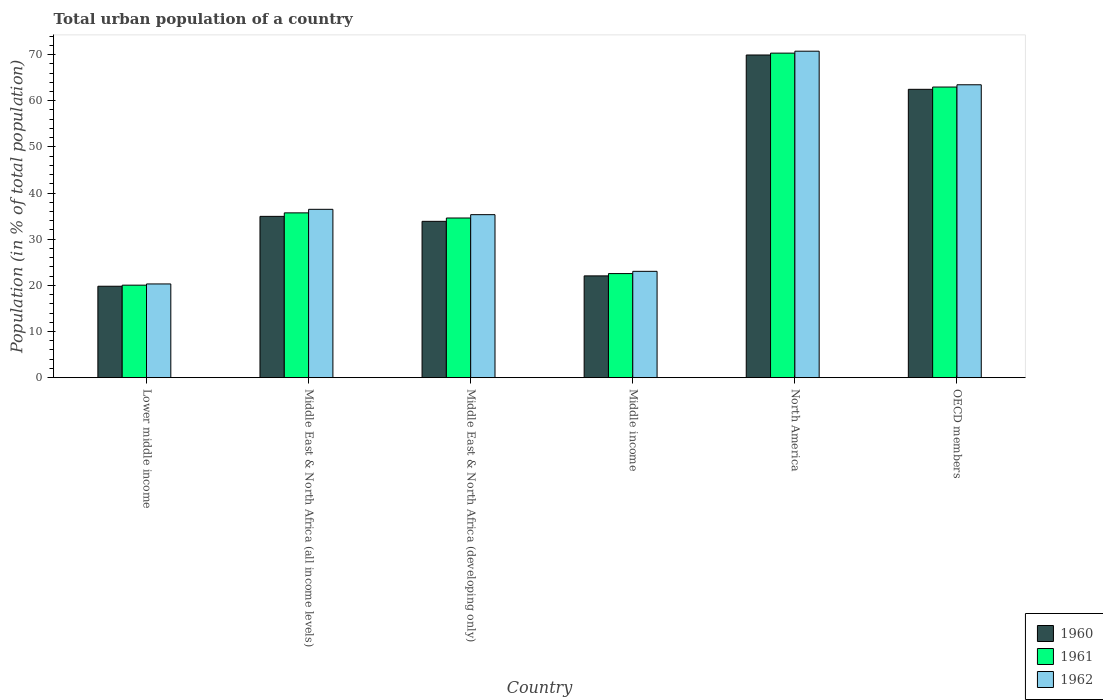How many different coloured bars are there?
Ensure brevity in your answer.  3. How many groups of bars are there?
Your response must be concise. 6. How many bars are there on the 3rd tick from the right?
Make the answer very short. 3. What is the label of the 2nd group of bars from the left?
Give a very brief answer. Middle East & North Africa (all income levels). In how many cases, is the number of bars for a given country not equal to the number of legend labels?
Your response must be concise. 0. What is the urban population in 1962 in North America?
Offer a very short reply. 70.74. Across all countries, what is the maximum urban population in 1960?
Your answer should be compact. 69.92. Across all countries, what is the minimum urban population in 1960?
Offer a very short reply. 19.81. In which country was the urban population in 1960 maximum?
Ensure brevity in your answer.  North America. In which country was the urban population in 1961 minimum?
Keep it short and to the point. Lower middle income. What is the total urban population in 1960 in the graph?
Provide a succinct answer. 243.09. What is the difference between the urban population in 1960 in Lower middle income and that in Middle East & North Africa (developing only)?
Your response must be concise. -14.06. What is the difference between the urban population in 1961 in Middle income and the urban population in 1962 in OECD members?
Provide a succinct answer. -40.91. What is the average urban population in 1962 per country?
Give a very brief answer. 41.56. What is the difference between the urban population of/in 1960 and urban population of/in 1961 in Middle East & North Africa (developing only)?
Your response must be concise. -0.72. In how many countries, is the urban population in 1960 greater than 34 %?
Your answer should be very brief. 3. What is the ratio of the urban population in 1962 in Middle East & North Africa (all income levels) to that in Middle East & North Africa (developing only)?
Make the answer very short. 1.03. Is the urban population in 1961 in Lower middle income less than that in Middle East & North Africa (all income levels)?
Your response must be concise. Yes. Is the difference between the urban population in 1960 in Middle income and North America greater than the difference between the urban population in 1961 in Middle income and North America?
Your answer should be compact. No. What is the difference between the highest and the second highest urban population in 1961?
Provide a succinct answer. 27.26. What is the difference between the highest and the lowest urban population in 1961?
Give a very brief answer. 50.28. Is the sum of the urban population in 1962 in Middle income and OECD members greater than the maximum urban population in 1960 across all countries?
Provide a short and direct response. Yes. What does the 1st bar from the right in Lower middle income represents?
Make the answer very short. 1962. Is it the case that in every country, the sum of the urban population in 1961 and urban population in 1962 is greater than the urban population in 1960?
Give a very brief answer. Yes. Are all the bars in the graph horizontal?
Make the answer very short. No. Are the values on the major ticks of Y-axis written in scientific E-notation?
Your response must be concise. No. Does the graph contain any zero values?
Make the answer very short. No. Does the graph contain grids?
Provide a short and direct response. No. Where does the legend appear in the graph?
Provide a short and direct response. Bottom right. How are the legend labels stacked?
Keep it short and to the point. Vertical. What is the title of the graph?
Ensure brevity in your answer.  Total urban population of a country. Does "2003" appear as one of the legend labels in the graph?
Provide a short and direct response. No. What is the label or title of the X-axis?
Provide a short and direct response. Country. What is the label or title of the Y-axis?
Make the answer very short. Population (in % of total population). What is the Population (in % of total population) in 1960 in Lower middle income?
Provide a succinct answer. 19.81. What is the Population (in % of total population) in 1961 in Lower middle income?
Provide a short and direct response. 20.04. What is the Population (in % of total population) in 1962 in Lower middle income?
Provide a succinct answer. 20.31. What is the Population (in % of total population) of 1960 in Middle East & North Africa (all income levels)?
Keep it short and to the point. 34.95. What is the Population (in % of total population) in 1961 in Middle East & North Africa (all income levels)?
Your answer should be compact. 35.71. What is the Population (in % of total population) of 1962 in Middle East & North Africa (all income levels)?
Your response must be concise. 36.48. What is the Population (in % of total population) in 1960 in Middle East & North Africa (developing only)?
Provide a short and direct response. 33.88. What is the Population (in % of total population) in 1961 in Middle East & North Africa (developing only)?
Provide a succinct answer. 34.6. What is the Population (in % of total population) in 1962 in Middle East & North Africa (developing only)?
Your answer should be very brief. 35.32. What is the Population (in % of total population) of 1960 in Middle income?
Give a very brief answer. 22.05. What is the Population (in % of total population) in 1961 in Middle income?
Make the answer very short. 22.55. What is the Population (in % of total population) in 1962 in Middle income?
Your answer should be very brief. 23.04. What is the Population (in % of total population) of 1960 in North America?
Provide a succinct answer. 69.92. What is the Population (in % of total population) of 1961 in North America?
Provide a succinct answer. 70.32. What is the Population (in % of total population) of 1962 in North America?
Provide a succinct answer. 70.74. What is the Population (in % of total population) in 1960 in OECD members?
Ensure brevity in your answer.  62.48. What is the Population (in % of total population) in 1961 in OECD members?
Offer a very short reply. 62.97. What is the Population (in % of total population) of 1962 in OECD members?
Your answer should be compact. 63.46. Across all countries, what is the maximum Population (in % of total population) in 1960?
Make the answer very short. 69.92. Across all countries, what is the maximum Population (in % of total population) of 1961?
Keep it short and to the point. 70.32. Across all countries, what is the maximum Population (in % of total population) in 1962?
Provide a succinct answer. 70.74. Across all countries, what is the minimum Population (in % of total population) in 1960?
Your response must be concise. 19.81. Across all countries, what is the minimum Population (in % of total population) in 1961?
Offer a terse response. 20.04. Across all countries, what is the minimum Population (in % of total population) of 1962?
Provide a short and direct response. 20.31. What is the total Population (in % of total population) in 1960 in the graph?
Keep it short and to the point. 243.09. What is the total Population (in % of total population) of 1961 in the graph?
Provide a succinct answer. 246.19. What is the total Population (in % of total population) of 1962 in the graph?
Provide a short and direct response. 249.35. What is the difference between the Population (in % of total population) of 1960 in Lower middle income and that in Middle East & North Africa (all income levels)?
Keep it short and to the point. -15.14. What is the difference between the Population (in % of total population) of 1961 in Lower middle income and that in Middle East & North Africa (all income levels)?
Ensure brevity in your answer.  -15.67. What is the difference between the Population (in % of total population) of 1962 in Lower middle income and that in Middle East & North Africa (all income levels)?
Ensure brevity in your answer.  -16.17. What is the difference between the Population (in % of total population) in 1960 in Lower middle income and that in Middle East & North Africa (developing only)?
Offer a very short reply. -14.06. What is the difference between the Population (in % of total population) in 1961 in Lower middle income and that in Middle East & North Africa (developing only)?
Give a very brief answer. -14.55. What is the difference between the Population (in % of total population) of 1962 in Lower middle income and that in Middle East & North Africa (developing only)?
Make the answer very short. -15.01. What is the difference between the Population (in % of total population) of 1960 in Lower middle income and that in Middle income?
Your answer should be compact. -2.24. What is the difference between the Population (in % of total population) in 1961 in Lower middle income and that in Middle income?
Ensure brevity in your answer.  -2.51. What is the difference between the Population (in % of total population) of 1962 in Lower middle income and that in Middle income?
Provide a short and direct response. -2.73. What is the difference between the Population (in % of total population) of 1960 in Lower middle income and that in North America?
Provide a short and direct response. -50.11. What is the difference between the Population (in % of total population) in 1961 in Lower middle income and that in North America?
Your answer should be compact. -50.28. What is the difference between the Population (in % of total population) of 1962 in Lower middle income and that in North America?
Keep it short and to the point. -50.43. What is the difference between the Population (in % of total population) of 1960 in Lower middle income and that in OECD members?
Keep it short and to the point. -42.67. What is the difference between the Population (in % of total population) in 1961 in Lower middle income and that in OECD members?
Ensure brevity in your answer.  -42.93. What is the difference between the Population (in % of total population) of 1962 in Lower middle income and that in OECD members?
Provide a short and direct response. -43.16. What is the difference between the Population (in % of total population) in 1960 in Middle East & North Africa (all income levels) and that in Middle East & North Africa (developing only)?
Provide a succinct answer. 1.08. What is the difference between the Population (in % of total population) in 1961 in Middle East & North Africa (all income levels) and that in Middle East & North Africa (developing only)?
Ensure brevity in your answer.  1.11. What is the difference between the Population (in % of total population) of 1962 in Middle East & North Africa (all income levels) and that in Middle East & North Africa (developing only)?
Your answer should be compact. 1.16. What is the difference between the Population (in % of total population) in 1960 in Middle East & North Africa (all income levels) and that in Middle income?
Provide a succinct answer. 12.9. What is the difference between the Population (in % of total population) of 1961 in Middle East & North Africa (all income levels) and that in Middle income?
Provide a succinct answer. 13.16. What is the difference between the Population (in % of total population) in 1962 in Middle East & North Africa (all income levels) and that in Middle income?
Provide a succinct answer. 13.44. What is the difference between the Population (in % of total population) of 1960 in Middle East & North Africa (all income levels) and that in North America?
Keep it short and to the point. -34.97. What is the difference between the Population (in % of total population) of 1961 in Middle East & North Africa (all income levels) and that in North America?
Offer a terse response. -34.61. What is the difference between the Population (in % of total population) in 1962 in Middle East & North Africa (all income levels) and that in North America?
Offer a terse response. -34.26. What is the difference between the Population (in % of total population) in 1960 in Middle East & North Africa (all income levels) and that in OECD members?
Your answer should be very brief. -27.53. What is the difference between the Population (in % of total population) of 1961 in Middle East & North Africa (all income levels) and that in OECD members?
Offer a terse response. -27.26. What is the difference between the Population (in % of total population) in 1962 in Middle East & North Africa (all income levels) and that in OECD members?
Your answer should be compact. -26.99. What is the difference between the Population (in % of total population) of 1960 in Middle East & North Africa (developing only) and that in Middle income?
Offer a very short reply. 11.82. What is the difference between the Population (in % of total population) of 1961 in Middle East & North Africa (developing only) and that in Middle income?
Offer a very short reply. 12.04. What is the difference between the Population (in % of total population) of 1962 in Middle East & North Africa (developing only) and that in Middle income?
Keep it short and to the point. 12.28. What is the difference between the Population (in % of total population) in 1960 in Middle East & North Africa (developing only) and that in North America?
Your answer should be very brief. -36.04. What is the difference between the Population (in % of total population) in 1961 in Middle East & North Africa (developing only) and that in North America?
Make the answer very short. -35.72. What is the difference between the Population (in % of total population) in 1962 in Middle East & North Africa (developing only) and that in North America?
Offer a terse response. -35.42. What is the difference between the Population (in % of total population) in 1960 in Middle East & North Africa (developing only) and that in OECD members?
Provide a succinct answer. -28.61. What is the difference between the Population (in % of total population) of 1961 in Middle East & North Africa (developing only) and that in OECD members?
Provide a short and direct response. -28.38. What is the difference between the Population (in % of total population) of 1962 in Middle East & North Africa (developing only) and that in OECD members?
Offer a very short reply. -28.15. What is the difference between the Population (in % of total population) in 1960 in Middle income and that in North America?
Your answer should be very brief. -47.87. What is the difference between the Population (in % of total population) in 1961 in Middle income and that in North America?
Offer a terse response. -47.77. What is the difference between the Population (in % of total population) in 1962 in Middle income and that in North America?
Offer a very short reply. -47.7. What is the difference between the Population (in % of total population) of 1960 in Middle income and that in OECD members?
Make the answer very short. -40.43. What is the difference between the Population (in % of total population) in 1961 in Middle income and that in OECD members?
Your answer should be compact. -40.42. What is the difference between the Population (in % of total population) of 1962 in Middle income and that in OECD members?
Give a very brief answer. -40.43. What is the difference between the Population (in % of total population) of 1960 in North America and that in OECD members?
Offer a very short reply. 7.44. What is the difference between the Population (in % of total population) of 1961 in North America and that in OECD members?
Your answer should be very brief. 7.35. What is the difference between the Population (in % of total population) of 1962 in North America and that in OECD members?
Your answer should be very brief. 7.28. What is the difference between the Population (in % of total population) of 1960 in Lower middle income and the Population (in % of total population) of 1961 in Middle East & North Africa (all income levels)?
Your answer should be compact. -15.9. What is the difference between the Population (in % of total population) of 1960 in Lower middle income and the Population (in % of total population) of 1962 in Middle East & North Africa (all income levels)?
Offer a very short reply. -16.67. What is the difference between the Population (in % of total population) of 1961 in Lower middle income and the Population (in % of total population) of 1962 in Middle East & North Africa (all income levels)?
Offer a very short reply. -16.43. What is the difference between the Population (in % of total population) in 1960 in Lower middle income and the Population (in % of total population) in 1961 in Middle East & North Africa (developing only)?
Your answer should be very brief. -14.79. What is the difference between the Population (in % of total population) in 1960 in Lower middle income and the Population (in % of total population) in 1962 in Middle East & North Africa (developing only)?
Your answer should be compact. -15.51. What is the difference between the Population (in % of total population) in 1961 in Lower middle income and the Population (in % of total population) in 1962 in Middle East & North Africa (developing only)?
Keep it short and to the point. -15.28. What is the difference between the Population (in % of total population) in 1960 in Lower middle income and the Population (in % of total population) in 1961 in Middle income?
Your response must be concise. -2.74. What is the difference between the Population (in % of total population) of 1960 in Lower middle income and the Population (in % of total population) of 1962 in Middle income?
Offer a terse response. -3.23. What is the difference between the Population (in % of total population) of 1961 in Lower middle income and the Population (in % of total population) of 1962 in Middle income?
Provide a succinct answer. -3. What is the difference between the Population (in % of total population) of 1960 in Lower middle income and the Population (in % of total population) of 1961 in North America?
Provide a short and direct response. -50.51. What is the difference between the Population (in % of total population) in 1960 in Lower middle income and the Population (in % of total population) in 1962 in North America?
Keep it short and to the point. -50.93. What is the difference between the Population (in % of total population) in 1961 in Lower middle income and the Population (in % of total population) in 1962 in North America?
Ensure brevity in your answer.  -50.7. What is the difference between the Population (in % of total population) in 1960 in Lower middle income and the Population (in % of total population) in 1961 in OECD members?
Ensure brevity in your answer.  -43.16. What is the difference between the Population (in % of total population) in 1960 in Lower middle income and the Population (in % of total population) in 1962 in OECD members?
Provide a short and direct response. -43.65. What is the difference between the Population (in % of total population) of 1961 in Lower middle income and the Population (in % of total population) of 1962 in OECD members?
Give a very brief answer. -43.42. What is the difference between the Population (in % of total population) of 1960 in Middle East & North Africa (all income levels) and the Population (in % of total population) of 1961 in Middle East & North Africa (developing only)?
Provide a short and direct response. 0.36. What is the difference between the Population (in % of total population) in 1960 in Middle East & North Africa (all income levels) and the Population (in % of total population) in 1962 in Middle East & North Africa (developing only)?
Ensure brevity in your answer.  -0.37. What is the difference between the Population (in % of total population) of 1961 in Middle East & North Africa (all income levels) and the Population (in % of total population) of 1962 in Middle East & North Africa (developing only)?
Give a very brief answer. 0.39. What is the difference between the Population (in % of total population) of 1960 in Middle East & North Africa (all income levels) and the Population (in % of total population) of 1961 in Middle income?
Give a very brief answer. 12.4. What is the difference between the Population (in % of total population) in 1960 in Middle East & North Africa (all income levels) and the Population (in % of total population) in 1962 in Middle income?
Your response must be concise. 11.91. What is the difference between the Population (in % of total population) of 1961 in Middle East & North Africa (all income levels) and the Population (in % of total population) of 1962 in Middle income?
Your answer should be compact. 12.67. What is the difference between the Population (in % of total population) of 1960 in Middle East & North Africa (all income levels) and the Population (in % of total population) of 1961 in North America?
Your response must be concise. -35.37. What is the difference between the Population (in % of total population) in 1960 in Middle East & North Africa (all income levels) and the Population (in % of total population) in 1962 in North America?
Make the answer very short. -35.79. What is the difference between the Population (in % of total population) in 1961 in Middle East & North Africa (all income levels) and the Population (in % of total population) in 1962 in North America?
Your answer should be very brief. -35.03. What is the difference between the Population (in % of total population) in 1960 in Middle East & North Africa (all income levels) and the Population (in % of total population) in 1961 in OECD members?
Provide a short and direct response. -28.02. What is the difference between the Population (in % of total population) in 1960 in Middle East & North Africa (all income levels) and the Population (in % of total population) in 1962 in OECD members?
Give a very brief answer. -28.51. What is the difference between the Population (in % of total population) of 1961 in Middle East & North Africa (all income levels) and the Population (in % of total population) of 1962 in OECD members?
Give a very brief answer. -27.76. What is the difference between the Population (in % of total population) of 1960 in Middle East & North Africa (developing only) and the Population (in % of total population) of 1961 in Middle income?
Keep it short and to the point. 11.32. What is the difference between the Population (in % of total population) in 1960 in Middle East & North Africa (developing only) and the Population (in % of total population) in 1962 in Middle income?
Make the answer very short. 10.84. What is the difference between the Population (in % of total population) of 1961 in Middle East & North Africa (developing only) and the Population (in % of total population) of 1962 in Middle income?
Your response must be concise. 11.56. What is the difference between the Population (in % of total population) of 1960 in Middle East & North Africa (developing only) and the Population (in % of total population) of 1961 in North America?
Keep it short and to the point. -36.44. What is the difference between the Population (in % of total population) of 1960 in Middle East & North Africa (developing only) and the Population (in % of total population) of 1962 in North America?
Your answer should be compact. -36.86. What is the difference between the Population (in % of total population) of 1961 in Middle East & North Africa (developing only) and the Population (in % of total population) of 1962 in North America?
Offer a terse response. -36.14. What is the difference between the Population (in % of total population) of 1960 in Middle East & North Africa (developing only) and the Population (in % of total population) of 1961 in OECD members?
Provide a short and direct response. -29.1. What is the difference between the Population (in % of total population) in 1960 in Middle East & North Africa (developing only) and the Population (in % of total population) in 1962 in OECD members?
Your response must be concise. -29.59. What is the difference between the Population (in % of total population) in 1961 in Middle East & North Africa (developing only) and the Population (in % of total population) in 1962 in OECD members?
Provide a succinct answer. -28.87. What is the difference between the Population (in % of total population) of 1960 in Middle income and the Population (in % of total population) of 1961 in North America?
Offer a very short reply. -48.27. What is the difference between the Population (in % of total population) in 1960 in Middle income and the Population (in % of total population) in 1962 in North America?
Offer a very short reply. -48.69. What is the difference between the Population (in % of total population) in 1961 in Middle income and the Population (in % of total population) in 1962 in North America?
Your response must be concise. -48.19. What is the difference between the Population (in % of total population) of 1960 in Middle income and the Population (in % of total population) of 1961 in OECD members?
Provide a short and direct response. -40.92. What is the difference between the Population (in % of total population) of 1960 in Middle income and the Population (in % of total population) of 1962 in OECD members?
Make the answer very short. -41.41. What is the difference between the Population (in % of total population) in 1961 in Middle income and the Population (in % of total population) in 1962 in OECD members?
Offer a very short reply. -40.91. What is the difference between the Population (in % of total population) in 1960 in North America and the Population (in % of total population) in 1961 in OECD members?
Offer a terse response. 6.95. What is the difference between the Population (in % of total population) in 1960 in North America and the Population (in % of total population) in 1962 in OECD members?
Keep it short and to the point. 6.45. What is the difference between the Population (in % of total population) of 1961 in North America and the Population (in % of total population) of 1962 in OECD members?
Your answer should be compact. 6.86. What is the average Population (in % of total population) in 1960 per country?
Offer a terse response. 40.51. What is the average Population (in % of total population) in 1961 per country?
Your response must be concise. 41.03. What is the average Population (in % of total population) in 1962 per country?
Your response must be concise. 41.56. What is the difference between the Population (in % of total population) of 1960 and Population (in % of total population) of 1961 in Lower middle income?
Your answer should be very brief. -0.23. What is the difference between the Population (in % of total population) in 1960 and Population (in % of total population) in 1962 in Lower middle income?
Keep it short and to the point. -0.5. What is the difference between the Population (in % of total population) in 1961 and Population (in % of total population) in 1962 in Lower middle income?
Offer a very short reply. -0.27. What is the difference between the Population (in % of total population) in 1960 and Population (in % of total population) in 1961 in Middle East & North Africa (all income levels)?
Give a very brief answer. -0.76. What is the difference between the Population (in % of total population) of 1960 and Population (in % of total population) of 1962 in Middle East & North Africa (all income levels)?
Make the answer very short. -1.53. What is the difference between the Population (in % of total population) in 1961 and Population (in % of total population) in 1962 in Middle East & North Africa (all income levels)?
Ensure brevity in your answer.  -0.77. What is the difference between the Population (in % of total population) of 1960 and Population (in % of total population) of 1961 in Middle East & North Africa (developing only)?
Your response must be concise. -0.72. What is the difference between the Population (in % of total population) of 1960 and Population (in % of total population) of 1962 in Middle East & North Africa (developing only)?
Ensure brevity in your answer.  -1.44. What is the difference between the Population (in % of total population) in 1961 and Population (in % of total population) in 1962 in Middle East & North Africa (developing only)?
Provide a succinct answer. -0.72. What is the difference between the Population (in % of total population) of 1960 and Population (in % of total population) of 1961 in Middle income?
Ensure brevity in your answer.  -0.5. What is the difference between the Population (in % of total population) in 1960 and Population (in % of total population) in 1962 in Middle income?
Offer a very short reply. -0.99. What is the difference between the Population (in % of total population) of 1961 and Population (in % of total population) of 1962 in Middle income?
Ensure brevity in your answer.  -0.49. What is the difference between the Population (in % of total population) of 1960 and Population (in % of total population) of 1961 in North America?
Make the answer very short. -0.4. What is the difference between the Population (in % of total population) in 1960 and Population (in % of total population) in 1962 in North America?
Keep it short and to the point. -0.82. What is the difference between the Population (in % of total population) of 1961 and Population (in % of total population) of 1962 in North America?
Keep it short and to the point. -0.42. What is the difference between the Population (in % of total population) of 1960 and Population (in % of total population) of 1961 in OECD members?
Offer a very short reply. -0.49. What is the difference between the Population (in % of total population) in 1960 and Population (in % of total population) in 1962 in OECD members?
Make the answer very short. -0.98. What is the difference between the Population (in % of total population) of 1961 and Population (in % of total population) of 1962 in OECD members?
Your response must be concise. -0.49. What is the ratio of the Population (in % of total population) in 1960 in Lower middle income to that in Middle East & North Africa (all income levels)?
Your answer should be compact. 0.57. What is the ratio of the Population (in % of total population) of 1961 in Lower middle income to that in Middle East & North Africa (all income levels)?
Your response must be concise. 0.56. What is the ratio of the Population (in % of total population) of 1962 in Lower middle income to that in Middle East & North Africa (all income levels)?
Your response must be concise. 0.56. What is the ratio of the Population (in % of total population) in 1960 in Lower middle income to that in Middle East & North Africa (developing only)?
Ensure brevity in your answer.  0.58. What is the ratio of the Population (in % of total population) in 1961 in Lower middle income to that in Middle East & North Africa (developing only)?
Offer a terse response. 0.58. What is the ratio of the Population (in % of total population) in 1962 in Lower middle income to that in Middle East & North Africa (developing only)?
Give a very brief answer. 0.57. What is the ratio of the Population (in % of total population) of 1960 in Lower middle income to that in Middle income?
Make the answer very short. 0.9. What is the ratio of the Population (in % of total population) in 1961 in Lower middle income to that in Middle income?
Provide a succinct answer. 0.89. What is the ratio of the Population (in % of total population) in 1962 in Lower middle income to that in Middle income?
Offer a terse response. 0.88. What is the ratio of the Population (in % of total population) of 1960 in Lower middle income to that in North America?
Give a very brief answer. 0.28. What is the ratio of the Population (in % of total population) of 1961 in Lower middle income to that in North America?
Keep it short and to the point. 0.28. What is the ratio of the Population (in % of total population) in 1962 in Lower middle income to that in North America?
Offer a very short reply. 0.29. What is the ratio of the Population (in % of total population) in 1960 in Lower middle income to that in OECD members?
Your answer should be compact. 0.32. What is the ratio of the Population (in % of total population) in 1961 in Lower middle income to that in OECD members?
Keep it short and to the point. 0.32. What is the ratio of the Population (in % of total population) in 1962 in Lower middle income to that in OECD members?
Offer a terse response. 0.32. What is the ratio of the Population (in % of total population) in 1960 in Middle East & North Africa (all income levels) to that in Middle East & North Africa (developing only)?
Your response must be concise. 1.03. What is the ratio of the Population (in % of total population) in 1961 in Middle East & North Africa (all income levels) to that in Middle East & North Africa (developing only)?
Your answer should be compact. 1.03. What is the ratio of the Population (in % of total population) in 1962 in Middle East & North Africa (all income levels) to that in Middle East & North Africa (developing only)?
Offer a terse response. 1.03. What is the ratio of the Population (in % of total population) in 1960 in Middle East & North Africa (all income levels) to that in Middle income?
Give a very brief answer. 1.58. What is the ratio of the Population (in % of total population) in 1961 in Middle East & North Africa (all income levels) to that in Middle income?
Provide a succinct answer. 1.58. What is the ratio of the Population (in % of total population) in 1962 in Middle East & North Africa (all income levels) to that in Middle income?
Make the answer very short. 1.58. What is the ratio of the Population (in % of total population) of 1960 in Middle East & North Africa (all income levels) to that in North America?
Your answer should be very brief. 0.5. What is the ratio of the Population (in % of total population) of 1961 in Middle East & North Africa (all income levels) to that in North America?
Your answer should be very brief. 0.51. What is the ratio of the Population (in % of total population) in 1962 in Middle East & North Africa (all income levels) to that in North America?
Give a very brief answer. 0.52. What is the ratio of the Population (in % of total population) in 1960 in Middle East & North Africa (all income levels) to that in OECD members?
Provide a succinct answer. 0.56. What is the ratio of the Population (in % of total population) in 1961 in Middle East & North Africa (all income levels) to that in OECD members?
Give a very brief answer. 0.57. What is the ratio of the Population (in % of total population) of 1962 in Middle East & North Africa (all income levels) to that in OECD members?
Ensure brevity in your answer.  0.57. What is the ratio of the Population (in % of total population) in 1960 in Middle East & North Africa (developing only) to that in Middle income?
Provide a short and direct response. 1.54. What is the ratio of the Population (in % of total population) of 1961 in Middle East & North Africa (developing only) to that in Middle income?
Provide a succinct answer. 1.53. What is the ratio of the Population (in % of total population) in 1962 in Middle East & North Africa (developing only) to that in Middle income?
Provide a succinct answer. 1.53. What is the ratio of the Population (in % of total population) in 1960 in Middle East & North Africa (developing only) to that in North America?
Your answer should be compact. 0.48. What is the ratio of the Population (in % of total population) in 1961 in Middle East & North Africa (developing only) to that in North America?
Your response must be concise. 0.49. What is the ratio of the Population (in % of total population) of 1962 in Middle East & North Africa (developing only) to that in North America?
Ensure brevity in your answer.  0.5. What is the ratio of the Population (in % of total population) in 1960 in Middle East & North Africa (developing only) to that in OECD members?
Give a very brief answer. 0.54. What is the ratio of the Population (in % of total population) in 1961 in Middle East & North Africa (developing only) to that in OECD members?
Provide a short and direct response. 0.55. What is the ratio of the Population (in % of total population) of 1962 in Middle East & North Africa (developing only) to that in OECD members?
Your answer should be compact. 0.56. What is the ratio of the Population (in % of total population) in 1960 in Middle income to that in North America?
Provide a short and direct response. 0.32. What is the ratio of the Population (in % of total population) of 1961 in Middle income to that in North America?
Your answer should be compact. 0.32. What is the ratio of the Population (in % of total population) in 1962 in Middle income to that in North America?
Give a very brief answer. 0.33. What is the ratio of the Population (in % of total population) in 1960 in Middle income to that in OECD members?
Keep it short and to the point. 0.35. What is the ratio of the Population (in % of total population) in 1961 in Middle income to that in OECD members?
Your response must be concise. 0.36. What is the ratio of the Population (in % of total population) in 1962 in Middle income to that in OECD members?
Ensure brevity in your answer.  0.36. What is the ratio of the Population (in % of total population) in 1960 in North America to that in OECD members?
Make the answer very short. 1.12. What is the ratio of the Population (in % of total population) in 1961 in North America to that in OECD members?
Your response must be concise. 1.12. What is the ratio of the Population (in % of total population) in 1962 in North America to that in OECD members?
Give a very brief answer. 1.11. What is the difference between the highest and the second highest Population (in % of total population) of 1960?
Your answer should be very brief. 7.44. What is the difference between the highest and the second highest Population (in % of total population) in 1961?
Make the answer very short. 7.35. What is the difference between the highest and the second highest Population (in % of total population) in 1962?
Give a very brief answer. 7.28. What is the difference between the highest and the lowest Population (in % of total population) of 1960?
Offer a terse response. 50.11. What is the difference between the highest and the lowest Population (in % of total population) in 1961?
Offer a terse response. 50.28. What is the difference between the highest and the lowest Population (in % of total population) of 1962?
Your answer should be very brief. 50.43. 